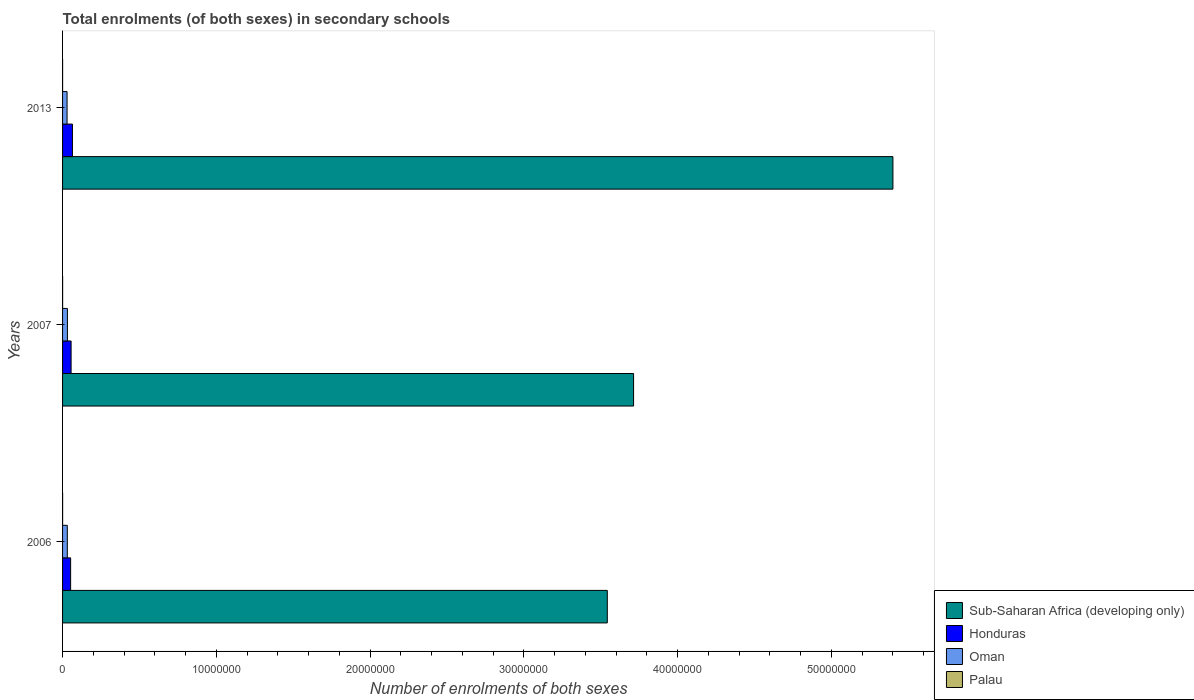How many groups of bars are there?
Make the answer very short. 3. What is the label of the 2nd group of bars from the top?
Provide a short and direct response. 2007. What is the number of enrolments in secondary schools in Sub-Saharan Africa (developing only) in 2006?
Your answer should be very brief. 3.54e+07. Across all years, what is the maximum number of enrolments in secondary schools in Palau?
Give a very brief answer. 2494. Across all years, what is the minimum number of enrolments in secondary schools in Honduras?
Offer a terse response. 5.24e+05. In which year was the number of enrolments in secondary schools in Honduras minimum?
Offer a very short reply. 2006. What is the total number of enrolments in secondary schools in Palau in the graph?
Ensure brevity in your answer.  6614. What is the difference between the number of enrolments in secondary schools in Oman in 2006 and that in 2013?
Your answer should be very brief. 1.57e+04. What is the difference between the number of enrolments in secondary schools in Honduras in 2007 and the number of enrolments in secondary schools in Oman in 2013?
Keep it short and to the point. 2.61e+05. What is the average number of enrolments in secondary schools in Oman per year?
Offer a very short reply. 3.06e+05. In the year 2007, what is the difference between the number of enrolments in secondary schools in Sub-Saharan Africa (developing only) and number of enrolments in secondary schools in Honduras?
Provide a short and direct response. 3.66e+07. In how many years, is the number of enrolments in secondary schools in Palau greater than 48000000 ?
Offer a terse response. 0. What is the ratio of the number of enrolments in secondary schools in Oman in 2007 to that in 2013?
Keep it short and to the point. 1.08. Is the number of enrolments in secondary schools in Oman in 2006 less than that in 2013?
Provide a succinct answer. No. What is the difference between the highest and the second highest number of enrolments in secondary schools in Honduras?
Keep it short and to the point. 8.84e+04. What is the difference between the highest and the lowest number of enrolments in secondary schools in Sub-Saharan Africa (developing only)?
Your answer should be very brief. 1.86e+07. In how many years, is the number of enrolments in secondary schools in Sub-Saharan Africa (developing only) greater than the average number of enrolments in secondary schools in Sub-Saharan Africa (developing only) taken over all years?
Keep it short and to the point. 1. What does the 2nd bar from the top in 2013 represents?
Make the answer very short. Oman. What does the 1st bar from the bottom in 2007 represents?
Your answer should be very brief. Sub-Saharan Africa (developing only). Is it the case that in every year, the sum of the number of enrolments in secondary schools in Sub-Saharan Africa (developing only) and number of enrolments in secondary schools in Honduras is greater than the number of enrolments in secondary schools in Palau?
Provide a short and direct response. Yes. How many bars are there?
Make the answer very short. 12. Are the values on the major ticks of X-axis written in scientific E-notation?
Your answer should be very brief. No. Does the graph contain any zero values?
Keep it short and to the point. No. How are the legend labels stacked?
Give a very brief answer. Vertical. What is the title of the graph?
Offer a terse response. Total enrolments (of both sexes) in secondary schools. What is the label or title of the X-axis?
Make the answer very short. Number of enrolments of both sexes. What is the label or title of the Y-axis?
Provide a succinct answer. Years. What is the Number of enrolments of both sexes in Sub-Saharan Africa (developing only) in 2006?
Ensure brevity in your answer.  3.54e+07. What is the Number of enrolments of both sexes of Honduras in 2006?
Your response must be concise. 5.24e+05. What is the Number of enrolments of both sexes in Oman in 2006?
Make the answer very short. 3.09e+05. What is the Number of enrolments of both sexes of Palau in 2006?
Give a very brief answer. 2494. What is the Number of enrolments of both sexes in Sub-Saharan Africa (developing only) in 2007?
Provide a short and direct response. 3.71e+07. What is the Number of enrolments of both sexes in Honduras in 2007?
Offer a very short reply. 5.54e+05. What is the Number of enrolments of both sexes in Oman in 2007?
Your answer should be very brief. 3.16e+05. What is the Number of enrolments of both sexes of Palau in 2007?
Make the answer very short. 2448. What is the Number of enrolments of both sexes of Sub-Saharan Africa (developing only) in 2013?
Give a very brief answer. 5.40e+07. What is the Number of enrolments of both sexes of Honduras in 2013?
Your answer should be compact. 6.43e+05. What is the Number of enrolments of both sexes in Oman in 2013?
Keep it short and to the point. 2.93e+05. What is the Number of enrolments of both sexes in Palau in 2013?
Offer a very short reply. 1672. Across all years, what is the maximum Number of enrolments of both sexes of Sub-Saharan Africa (developing only)?
Offer a very short reply. 5.40e+07. Across all years, what is the maximum Number of enrolments of both sexes of Honduras?
Make the answer very short. 6.43e+05. Across all years, what is the maximum Number of enrolments of both sexes of Oman?
Provide a succinct answer. 3.16e+05. Across all years, what is the maximum Number of enrolments of both sexes in Palau?
Provide a succinct answer. 2494. Across all years, what is the minimum Number of enrolments of both sexes of Sub-Saharan Africa (developing only)?
Keep it short and to the point. 3.54e+07. Across all years, what is the minimum Number of enrolments of both sexes of Honduras?
Your answer should be very brief. 5.24e+05. Across all years, what is the minimum Number of enrolments of both sexes of Oman?
Your answer should be compact. 2.93e+05. Across all years, what is the minimum Number of enrolments of both sexes of Palau?
Offer a very short reply. 1672. What is the total Number of enrolments of both sexes of Sub-Saharan Africa (developing only) in the graph?
Offer a terse response. 1.27e+08. What is the total Number of enrolments of both sexes in Honduras in the graph?
Ensure brevity in your answer.  1.72e+06. What is the total Number of enrolments of both sexes in Oman in the graph?
Your response must be concise. 9.17e+05. What is the total Number of enrolments of both sexes of Palau in the graph?
Provide a succinct answer. 6614. What is the difference between the Number of enrolments of both sexes of Sub-Saharan Africa (developing only) in 2006 and that in 2007?
Keep it short and to the point. -1.71e+06. What is the difference between the Number of enrolments of both sexes of Honduras in 2006 and that in 2007?
Offer a terse response. -2.99e+04. What is the difference between the Number of enrolments of both sexes of Oman in 2006 and that in 2007?
Make the answer very short. -7511. What is the difference between the Number of enrolments of both sexes in Sub-Saharan Africa (developing only) in 2006 and that in 2013?
Ensure brevity in your answer.  -1.86e+07. What is the difference between the Number of enrolments of both sexes of Honduras in 2006 and that in 2013?
Offer a terse response. -1.18e+05. What is the difference between the Number of enrolments of both sexes in Oman in 2006 and that in 2013?
Give a very brief answer. 1.57e+04. What is the difference between the Number of enrolments of both sexes in Palau in 2006 and that in 2013?
Provide a short and direct response. 822. What is the difference between the Number of enrolments of both sexes in Sub-Saharan Africa (developing only) in 2007 and that in 2013?
Offer a terse response. -1.69e+07. What is the difference between the Number of enrolments of both sexes in Honduras in 2007 and that in 2013?
Make the answer very short. -8.84e+04. What is the difference between the Number of enrolments of both sexes in Oman in 2007 and that in 2013?
Provide a succinct answer. 2.32e+04. What is the difference between the Number of enrolments of both sexes of Palau in 2007 and that in 2013?
Keep it short and to the point. 776. What is the difference between the Number of enrolments of both sexes of Sub-Saharan Africa (developing only) in 2006 and the Number of enrolments of both sexes of Honduras in 2007?
Provide a short and direct response. 3.49e+07. What is the difference between the Number of enrolments of both sexes in Sub-Saharan Africa (developing only) in 2006 and the Number of enrolments of both sexes in Oman in 2007?
Your answer should be compact. 3.51e+07. What is the difference between the Number of enrolments of both sexes of Sub-Saharan Africa (developing only) in 2006 and the Number of enrolments of both sexes of Palau in 2007?
Make the answer very short. 3.54e+07. What is the difference between the Number of enrolments of both sexes in Honduras in 2006 and the Number of enrolments of both sexes in Oman in 2007?
Your answer should be compact. 2.08e+05. What is the difference between the Number of enrolments of both sexes of Honduras in 2006 and the Number of enrolments of both sexes of Palau in 2007?
Provide a succinct answer. 5.22e+05. What is the difference between the Number of enrolments of both sexes of Oman in 2006 and the Number of enrolments of both sexes of Palau in 2007?
Offer a very short reply. 3.06e+05. What is the difference between the Number of enrolments of both sexes in Sub-Saharan Africa (developing only) in 2006 and the Number of enrolments of both sexes in Honduras in 2013?
Give a very brief answer. 3.48e+07. What is the difference between the Number of enrolments of both sexes of Sub-Saharan Africa (developing only) in 2006 and the Number of enrolments of both sexes of Oman in 2013?
Offer a terse response. 3.51e+07. What is the difference between the Number of enrolments of both sexes of Sub-Saharan Africa (developing only) in 2006 and the Number of enrolments of both sexes of Palau in 2013?
Make the answer very short. 3.54e+07. What is the difference between the Number of enrolments of both sexes of Honduras in 2006 and the Number of enrolments of both sexes of Oman in 2013?
Give a very brief answer. 2.32e+05. What is the difference between the Number of enrolments of both sexes of Honduras in 2006 and the Number of enrolments of both sexes of Palau in 2013?
Offer a very short reply. 5.23e+05. What is the difference between the Number of enrolments of both sexes of Oman in 2006 and the Number of enrolments of both sexes of Palau in 2013?
Your answer should be very brief. 3.07e+05. What is the difference between the Number of enrolments of both sexes of Sub-Saharan Africa (developing only) in 2007 and the Number of enrolments of both sexes of Honduras in 2013?
Your response must be concise. 3.65e+07. What is the difference between the Number of enrolments of both sexes of Sub-Saharan Africa (developing only) in 2007 and the Number of enrolments of both sexes of Oman in 2013?
Offer a very short reply. 3.68e+07. What is the difference between the Number of enrolments of both sexes in Sub-Saharan Africa (developing only) in 2007 and the Number of enrolments of both sexes in Palau in 2013?
Make the answer very short. 3.71e+07. What is the difference between the Number of enrolments of both sexes in Honduras in 2007 and the Number of enrolments of both sexes in Oman in 2013?
Your response must be concise. 2.61e+05. What is the difference between the Number of enrolments of both sexes in Honduras in 2007 and the Number of enrolments of both sexes in Palau in 2013?
Provide a succinct answer. 5.53e+05. What is the difference between the Number of enrolments of both sexes of Oman in 2007 and the Number of enrolments of both sexes of Palau in 2013?
Provide a succinct answer. 3.14e+05. What is the average Number of enrolments of both sexes of Sub-Saharan Africa (developing only) per year?
Provide a short and direct response. 4.22e+07. What is the average Number of enrolments of both sexes in Honduras per year?
Ensure brevity in your answer.  5.74e+05. What is the average Number of enrolments of both sexes of Oman per year?
Give a very brief answer. 3.06e+05. What is the average Number of enrolments of both sexes of Palau per year?
Provide a succinct answer. 2204.67. In the year 2006, what is the difference between the Number of enrolments of both sexes in Sub-Saharan Africa (developing only) and Number of enrolments of both sexes in Honduras?
Give a very brief answer. 3.49e+07. In the year 2006, what is the difference between the Number of enrolments of both sexes of Sub-Saharan Africa (developing only) and Number of enrolments of both sexes of Oman?
Your answer should be compact. 3.51e+07. In the year 2006, what is the difference between the Number of enrolments of both sexes in Sub-Saharan Africa (developing only) and Number of enrolments of both sexes in Palau?
Make the answer very short. 3.54e+07. In the year 2006, what is the difference between the Number of enrolments of both sexes in Honduras and Number of enrolments of both sexes in Oman?
Provide a succinct answer. 2.16e+05. In the year 2006, what is the difference between the Number of enrolments of both sexes in Honduras and Number of enrolments of both sexes in Palau?
Your answer should be compact. 5.22e+05. In the year 2006, what is the difference between the Number of enrolments of both sexes in Oman and Number of enrolments of both sexes in Palau?
Offer a terse response. 3.06e+05. In the year 2007, what is the difference between the Number of enrolments of both sexes in Sub-Saharan Africa (developing only) and Number of enrolments of both sexes in Honduras?
Provide a succinct answer. 3.66e+07. In the year 2007, what is the difference between the Number of enrolments of both sexes in Sub-Saharan Africa (developing only) and Number of enrolments of both sexes in Oman?
Your answer should be very brief. 3.68e+07. In the year 2007, what is the difference between the Number of enrolments of both sexes of Sub-Saharan Africa (developing only) and Number of enrolments of both sexes of Palau?
Give a very brief answer. 3.71e+07. In the year 2007, what is the difference between the Number of enrolments of both sexes in Honduras and Number of enrolments of both sexes in Oman?
Offer a very short reply. 2.38e+05. In the year 2007, what is the difference between the Number of enrolments of both sexes of Honduras and Number of enrolments of both sexes of Palau?
Provide a short and direct response. 5.52e+05. In the year 2007, what is the difference between the Number of enrolments of both sexes in Oman and Number of enrolments of both sexes in Palau?
Your answer should be very brief. 3.14e+05. In the year 2013, what is the difference between the Number of enrolments of both sexes in Sub-Saharan Africa (developing only) and Number of enrolments of both sexes in Honduras?
Your answer should be very brief. 5.34e+07. In the year 2013, what is the difference between the Number of enrolments of both sexes of Sub-Saharan Africa (developing only) and Number of enrolments of both sexes of Oman?
Offer a terse response. 5.37e+07. In the year 2013, what is the difference between the Number of enrolments of both sexes in Sub-Saharan Africa (developing only) and Number of enrolments of both sexes in Palau?
Keep it short and to the point. 5.40e+07. In the year 2013, what is the difference between the Number of enrolments of both sexes in Honduras and Number of enrolments of both sexes in Oman?
Give a very brief answer. 3.50e+05. In the year 2013, what is the difference between the Number of enrolments of both sexes of Honduras and Number of enrolments of both sexes of Palau?
Your answer should be compact. 6.41e+05. In the year 2013, what is the difference between the Number of enrolments of both sexes of Oman and Number of enrolments of both sexes of Palau?
Your answer should be compact. 2.91e+05. What is the ratio of the Number of enrolments of both sexes in Sub-Saharan Africa (developing only) in 2006 to that in 2007?
Offer a terse response. 0.95. What is the ratio of the Number of enrolments of both sexes in Honduras in 2006 to that in 2007?
Your response must be concise. 0.95. What is the ratio of the Number of enrolments of both sexes in Oman in 2006 to that in 2007?
Make the answer very short. 0.98. What is the ratio of the Number of enrolments of both sexes in Palau in 2006 to that in 2007?
Offer a very short reply. 1.02. What is the ratio of the Number of enrolments of both sexes in Sub-Saharan Africa (developing only) in 2006 to that in 2013?
Provide a succinct answer. 0.66. What is the ratio of the Number of enrolments of both sexes of Honduras in 2006 to that in 2013?
Offer a terse response. 0.82. What is the ratio of the Number of enrolments of both sexes in Oman in 2006 to that in 2013?
Provide a short and direct response. 1.05. What is the ratio of the Number of enrolments of both sexes of Palau in 2006 to that in 2013?
Give a very brief answer. 1.49. What is the ratio of the Number of enrolments of both sexes of Sub-Saharan Africa (developing only) in 2007 to that in 2013?
Ensure brevity in your answer.  0.69. What is the ratio of the Number of enrolments of both sexes of Honduras in 2007 to that in 2013?
Offer a very short reply. 0.86. What is the ratio of the Number of enrolments of both sexes of Oman in 2007 to that in 2013?
Keep it short and to the point. 1.08. What is the ratio of the Number of enrolments of both sexes of Palau in 2007 to that in 2013?
Your response must be concise. 1.46. What is the difference between the highest and the second highest Number of enrolments of both sexes in Sub-Saharan Africa (developing only)?
Ensure brevity in your answer.  1.69e+07. What is the difference between the highest and the second highest Number of enrolments of both sexes of Honduras?
Provide a succinct answer. 8.84e+04. What is the difference between the highest and the second highest Number of enrolments of both sexes of Oman?
Provide a short and direct response. 7511. What is the difference between the highest and the second highest Number of enrolments of both sexes of Palau?
Your answer should be compact. 46. What is the difference between the highest and the lowest Number of enrolments of both sexes of Sub-Saharan Africa (developing only)?
Keep it short and to the point. 1.86e+07. What is the difference between the highest and the lowest Number of enrolments of both sexes in Honduras?
Ensure brevity in your answer.  1.18e+05. What is the difference between the highest and the lowest Number of enrolments of both sexes in Oman?
Give a very brief answer. 2.32e+04. What is the difference between the highest and the lowest Number of enrolments of both sexes in Palau?
Provide a short and direct response. 822. 